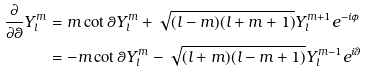Convert formula to latex. <formula><loc_0><loc_0><loc_500><loc_500>\frac { \partial } { \partial \theta } Y ^ { m } _ { l } & = m \cot \theta Y ^ { m } _ { l } + \sqrt { ( l - m ) ( l + m + 1 ) } Y ^ { m + 1 } _ { l } e ^ { - i \phi } \\ & = - m \cot \theta Y ^ { m } _ { l } - \sqrt { ( l + m ) ( l - m + 1 ) } Y ^ { m - 1 } _ { l } e ^ { i \theta }</formula> 